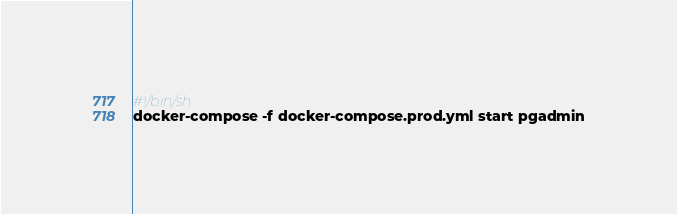<code> <loc_0><loc_0><loc_500><loc_500><_Bash_>#!/bin/sh
docker-compose -f docker-compose.prod.yml start pgadmin</code> 